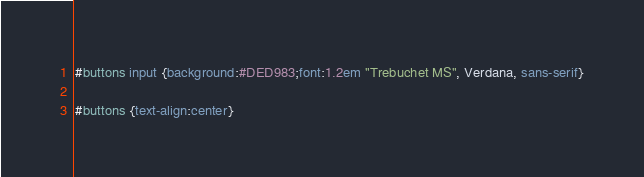<code> <loc_0><loc_0><loc_500><loc_500><_CSS_>#buttons input {background:#DED983;font:1.2em "Trebuchet MS", Verdana, sans-serif}

#buttons {text-align:center}</code> 